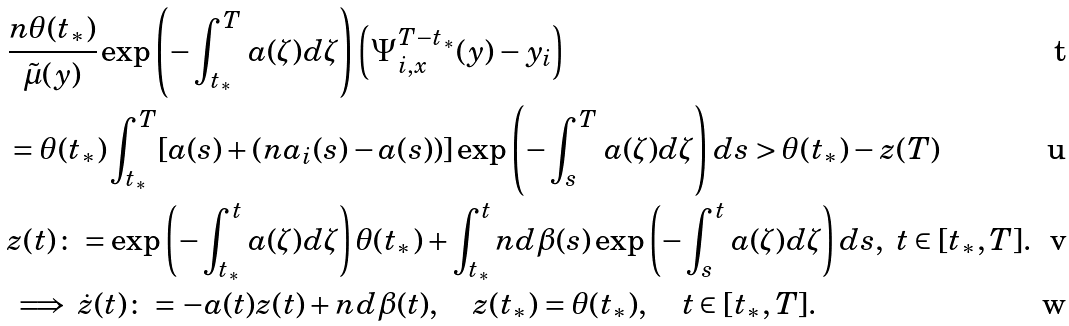Convert formula to latex. <formula><loc_0><loc_0><loc_500><loc_500>& \frac { n \theta ( t _ { * } ) } { \tilde { \mu } ( y ) } \exp \left ( - \int _ { t _ { * } } ^ { T } \, a ( \zeta ) d \zeta \right ) \left ( { \Psi _ { i , x } ^ { T - t _ { * } } ( y ) - y _ { i } } \right ) \\ & = \theta ( t _ { * } ) \int _ { t _ { * } } ^ { T } [ a ( s ) + ( n a _ { i } ( s ) - a ( s ) ) ] \exp \left ( - \int _ { s } ^ { T } \, a ( \zeta ) d \zeta \right ) d s > \theta ( t _ { * } ) - z ( T ) \\ & z ( t ) \colon = \exp \left ( - \int _ { t _ { * } } ^ { t } \, a ( \zeta ) d \zeta \right ) \theta ( t _ { * } ) + \int _ { t _ { * } } ^ { t } n d \beta ( s ) \exp \left ( - \int _ { s } ^ { t } \, a ( \zeta ) d \zeta \right ) d s , \ t \in [ t _ { * } , T ] . \\ & \implies \dot { z } ( t ) \colon = - a ( t ) z ( t ) + n d \beta ( t ) , \quad z ( t _ { * } ) = \theta ( t _ { * } ) , \quad t \in [ t _ { * } , T ] .</formula> 